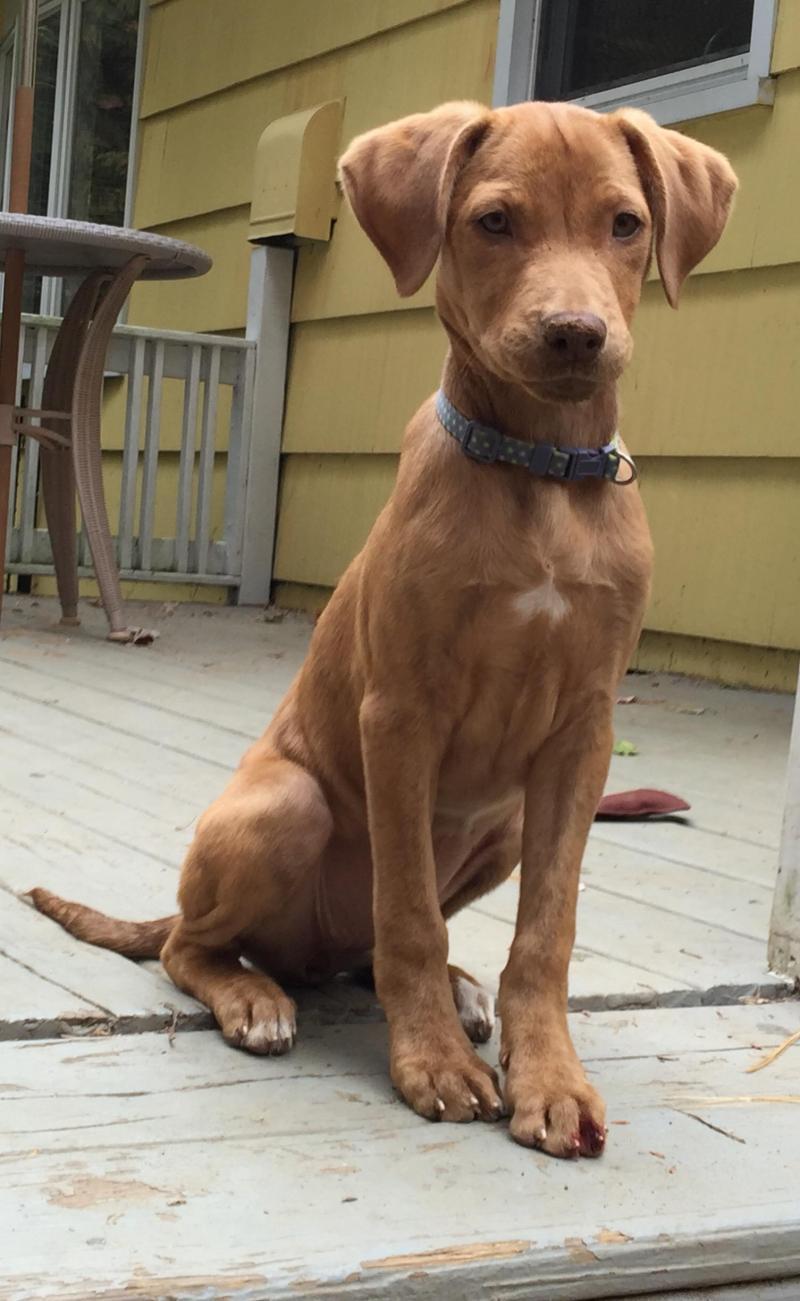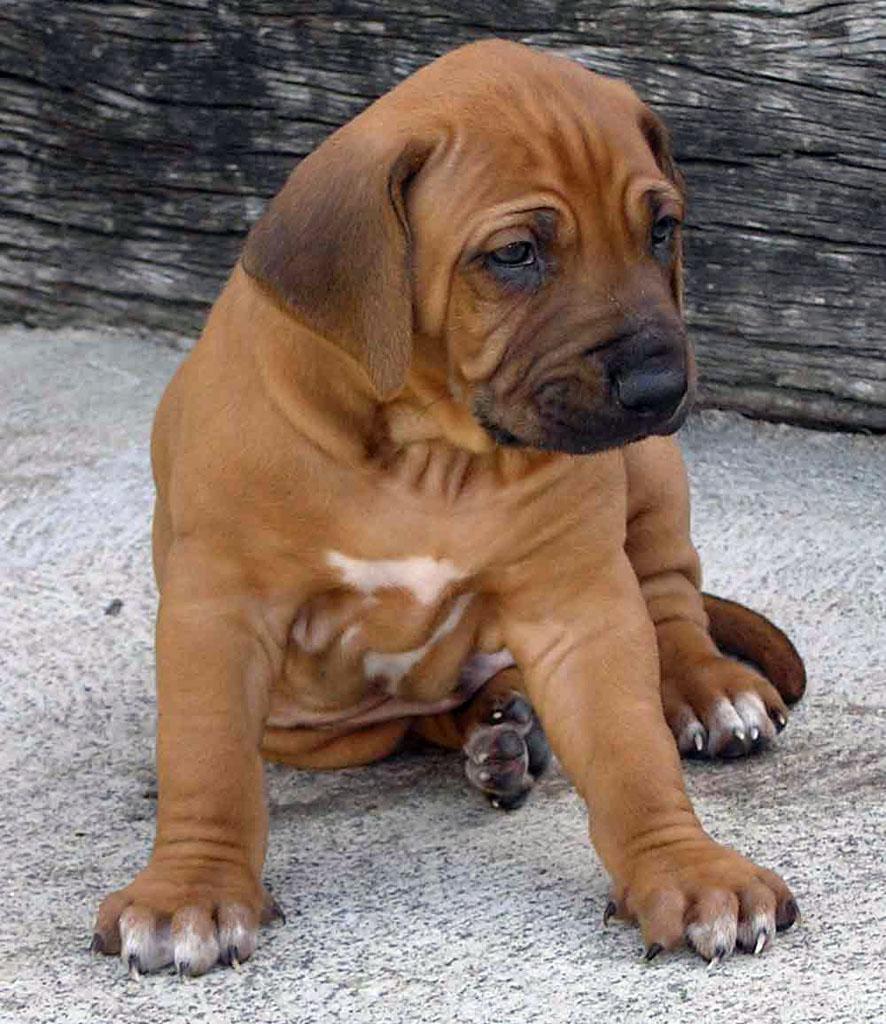The first image is the image on the left, the second image is the image on the right. Analyze the images presented: Is the assertion "All the dogs are sitting." valid? Answer yes or no. Yes. The first image is the image on the left, the second image is the image on the right. Examine the images to the left and right. Is the description "Each image shows a single red-orange dog sitting upright, and at least one of the dogs depicted is wearing a collar." accurate? Answer yes or no. Yes. 